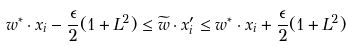<formula> <loc_0><loc_0><loc_500><loc_500>w ^ { * } \cdot x _ { i } - \frac { \epsilon } { 2 } ( 1 + L ^ { 2 } ) \leq \widetilde { w } \cdot x _ { i } ^ { \prime } \leq w ^ { * } \cdot x _ { i } + \frac { \epsilon } { 2 } ( 1 + L ^ { 2 } )</formula> 